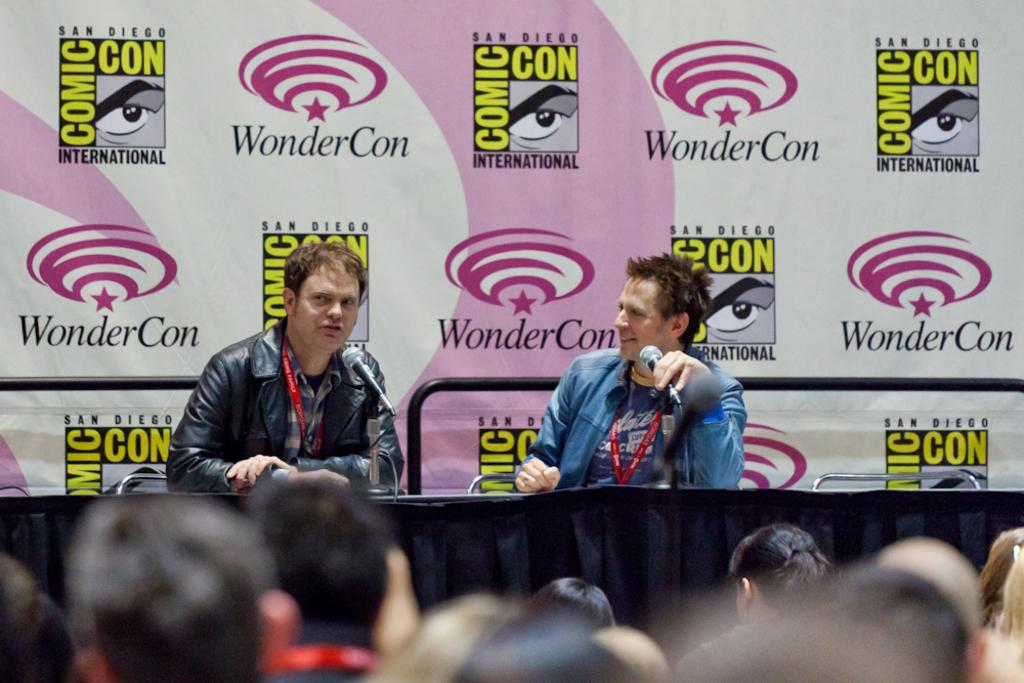How many people are in the image? There is a group of people in the image. Can you describe the two men in front of the group? There are two men in front of the group. What objects are in front of the group? There are microphones, a cloth, chairs, and a banner in front of the group. What type of dog can be seen gripping the banner in the image? There is no dog present in the image, and therefore no such activity can be observed. 